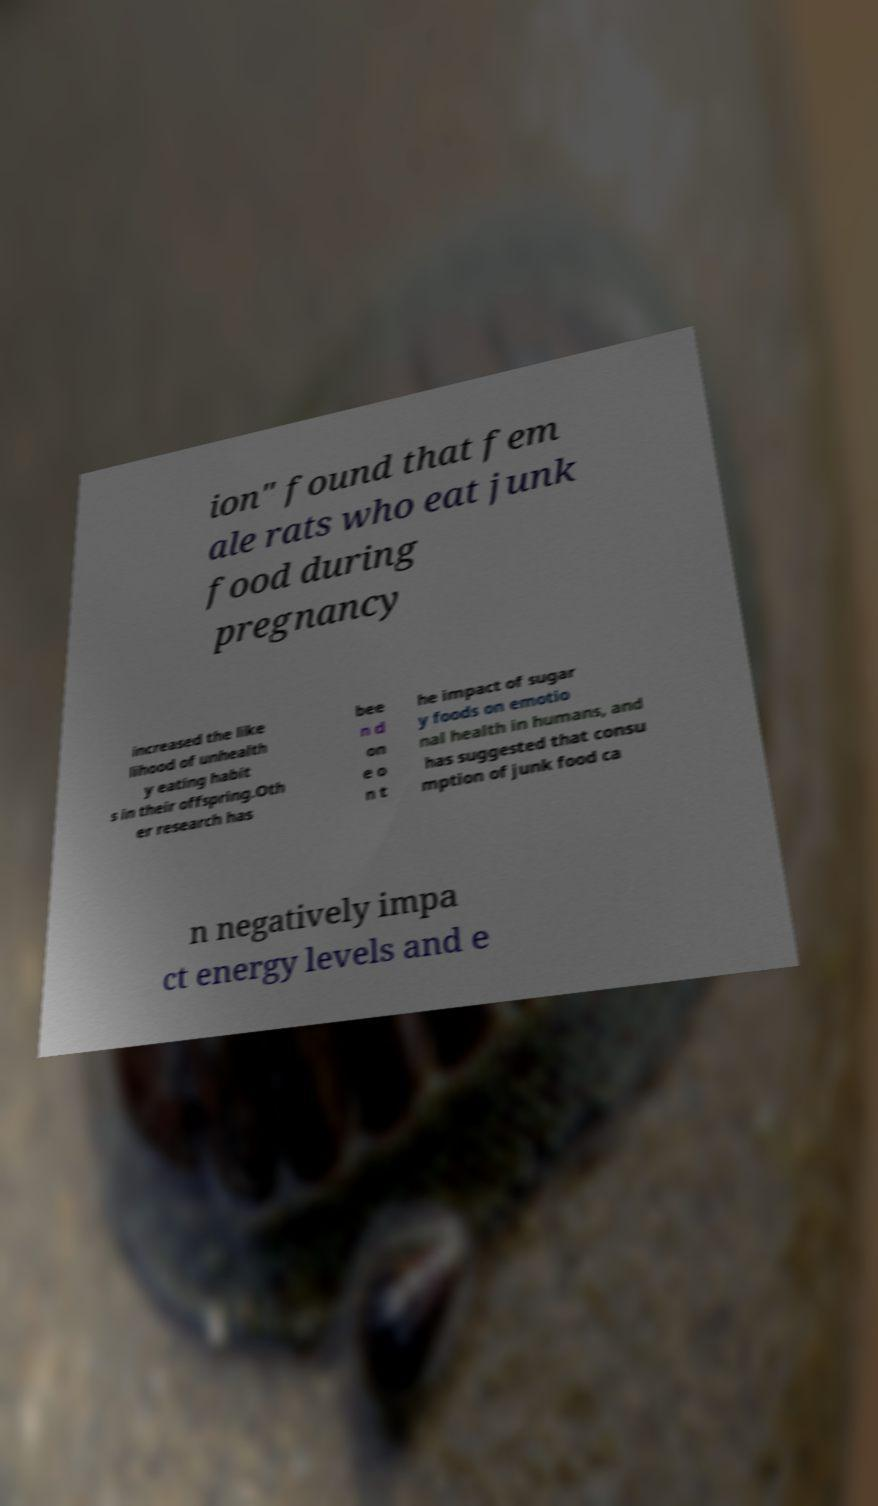Can you accurately transcribe the text from the provided image for me? ion" found that fem ale rats who eat junk food during pregnancy increased the like lihood of unhealth y eating habit s in their offspring.Oth er research has bee n d on e o n t he impact of sugar y foods on emotio nal health in humans, and has suggested that consu mption of junk food ca n negatively impa ct energy levels and e 